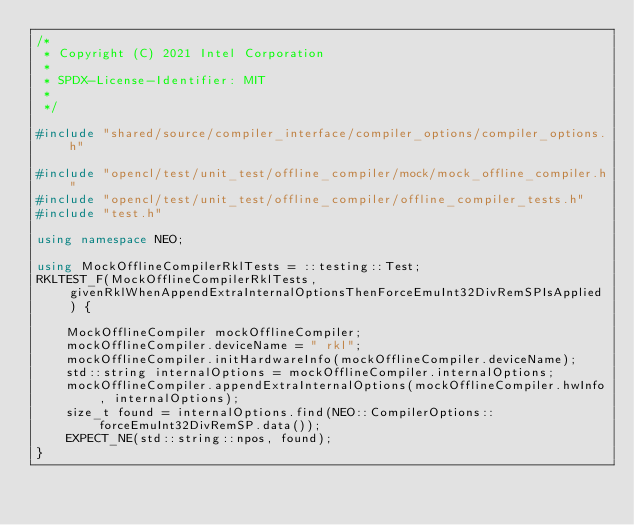<code> <loc_0><loc_0><loc_500><loc_500><_C++_>/*
 * Copyright (C) 2021 Intel Corporation
 *
 * SPDX-License-Identifier: MIT
 *
 */

#include "shared/source/compiler_interface/compiler_options/compiler_options.h"

#include "opencl/test/unit_test/offline_compiler/mock/mock_offline_compiler.h"
#include "opencl/test/unit_test/offline_compiler/offline_compiler_tests.h"
#include "test.h"

using namespace NEO;

using MockOfflineCompilerRklTests = ::testing::Test;
RKLTEST_F(MockOfflineCompilerRklTests, givenRklWhenAppendExtraInternalOptionsThenForceEmuInt32DivRemSPIsApplied) {

    MockOfflineCompiler mockOfflineCompiler;
    mockOfflineCompiler.deviceName = " rkl";
    mockOfflineCompiler.initHardwareInfo(mockOfflineCompiler.deviceName);
    std::string internalOptions = mockOfflineCompiler.internalOptions;
    mockOfflineCompiler.appendExtraInternalOptions(mockOfflineCompiler.hwInfo, internalOptions);
    size_t found = internalOptions.find(NEO::CompilerOptions::forceEmuInt32DivRemSP.data());
    EXPECT_NE(std::string::npos, found);
}
</code> 